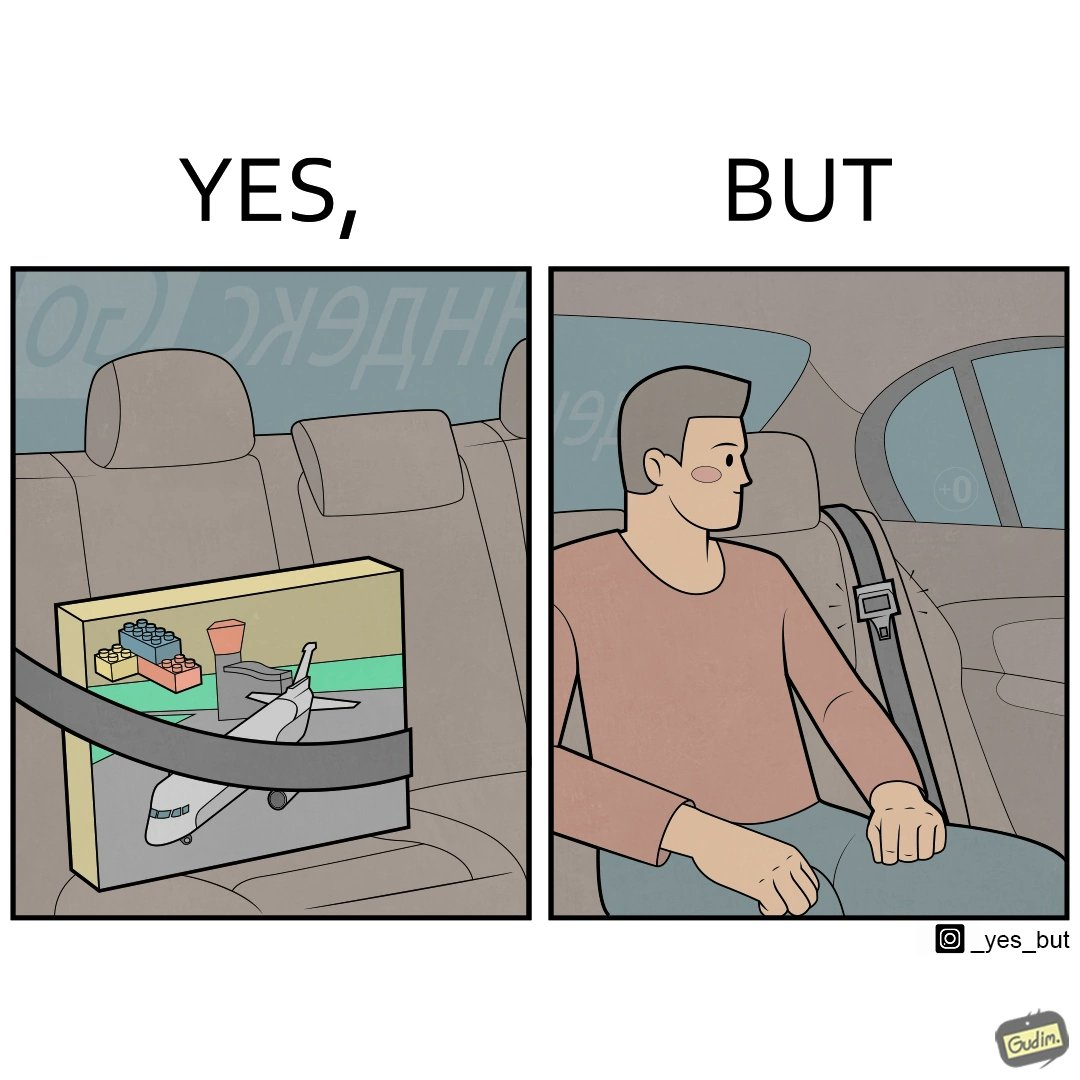Is there satirical content in this image? Yes, this image is satirical. 